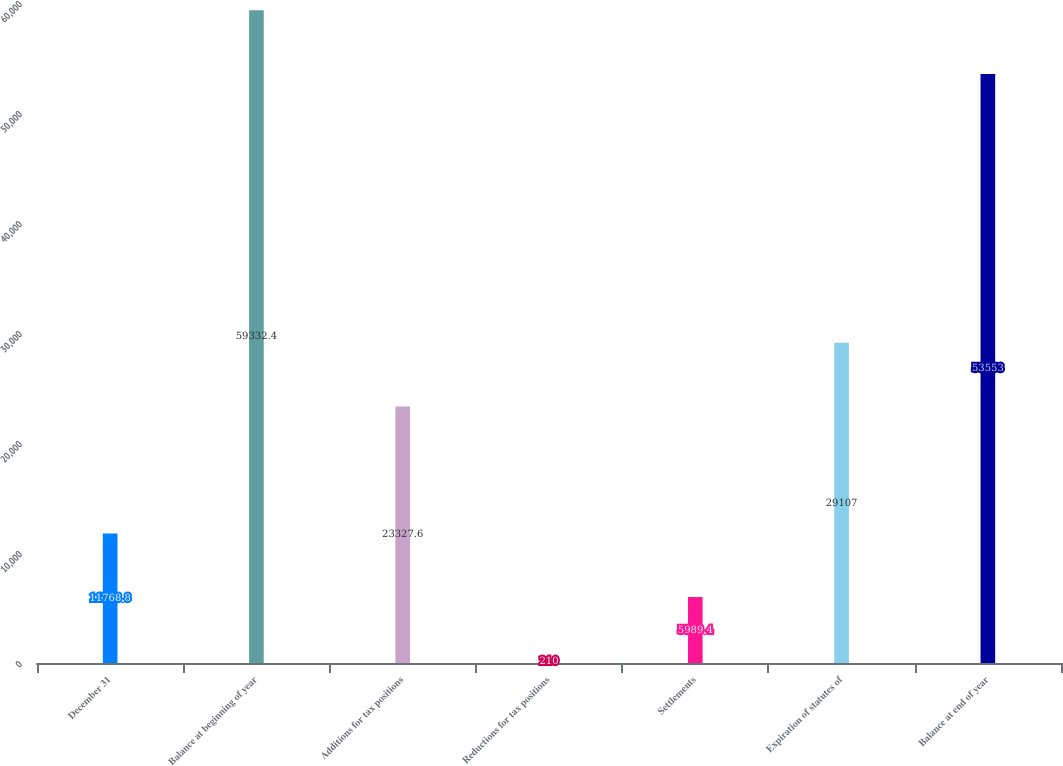Convert chart. <chart><loc_0><loc_0><loc_500><loc_500><bar_chart><fcel>December 31<fcel>Balance at beginning of year<fcel>Additions for tax positions<fcel>Reductions for tax positions<fcel>Settlements<fcel>Expiration of statutes of<fcel>Balance at end of year<nl><fcel>11768.8<fcel>59332.4<fcel>23327.6<fcel>210<fcel>5989.4<fcel>29107<fcel>53553<nl></chart> 